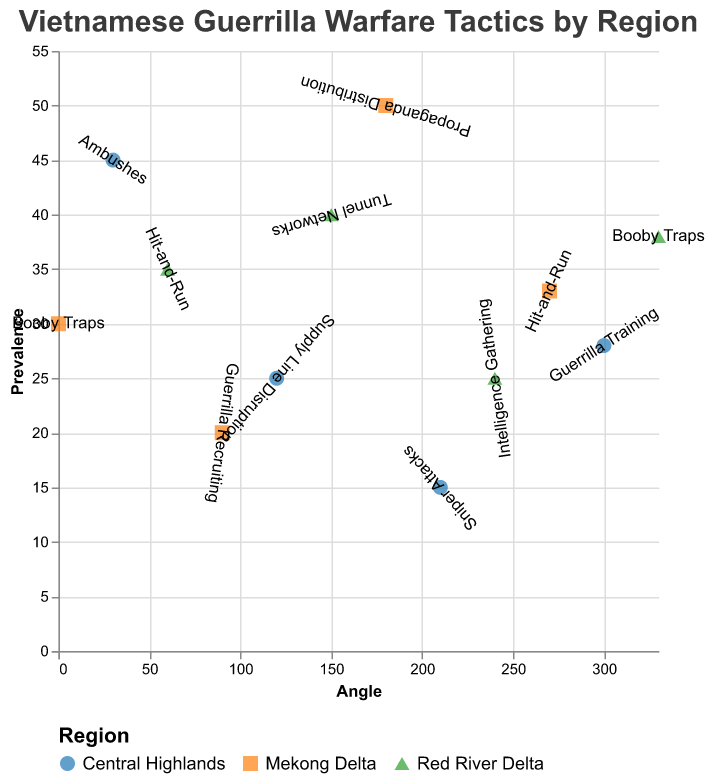What's the title of the figure? The title is located at the top of the figure, displayed in larger and bolder text compared to other elements. It reads "Vietnamese Guerrilla Warfare Tactics by Region".
Answer: Vietnamese Guerrilla Warfare Tactics by Region How many distinct regions are represented in the figure? By looking at the legend or the color/shape distinctions, we can see that there are three distinct regions: Mekong Delta, Central Highlands, and Red River Delta.
Answer: Three Which tactic has the highest prevalence in the Mekong Delta? We identify the Mekong Delta points on the chart and read the prevalence values. Propaganda Distribution has the highest prevalence at 50.
Answer: Propaganda Distribution What’s the prevalence difference between Ambushes in the Central Highlands and Hit-and-Run in the Red River Delta? Locate the data points for Ambushes in the Central Highlands (prevalence 45) and Hit-and-Run in the Red River Delta (prevalence 35). Subtract the smaller value from the larger value: 45 - 35 = 10.
Answer: 10 Which tactic is located at the 0-degree angle? By checking the angle values and corresponding tactics, we find that Booby Traps is at 0 degrees in the Mekong Delta.
Answer: Booby Traps Arrange the regions by their highest tactic prevalence, descending. Examine the highest prevalence value for each region: Mekong Delta (Propaganda Distribution, 50), Central Highlands (Ambushes, 45), and Red River Delta (Tunnel Networks, 40). Order them from highest to lowest.
Answer: Mekong Delta, Central Highlands, Red River Delta Which region employs Hit-and-Run tactics and what are their respective prevalences? Identify the Hit-and-Run tactics and note both corresponding regions and prevalences: Red River Delta (35) and Mekong Delta (33).
Answer: Red River Delta (35), Mekong Delta (33) What is the average prevalence of tactics in the Central Highlands? Calculate using the prevalence values associated with the Central Highlands: Ambushes (45), Supply Line Disruption (25), Sniper Attacks (15), Guerrilla Training (28). The average is (45+25+15+28) / 4 = 113 / 4 = 28.25.
Answer: 28.25 Which regions utilize Booby Traps, and how do their prevalences compare? Identify the regions using Booby Traps and their prevalences: Mekong Delta (30), Red River Delta (38). Compare the two values.
Answer: Mekong Delta (30), Red River Delta (38) 